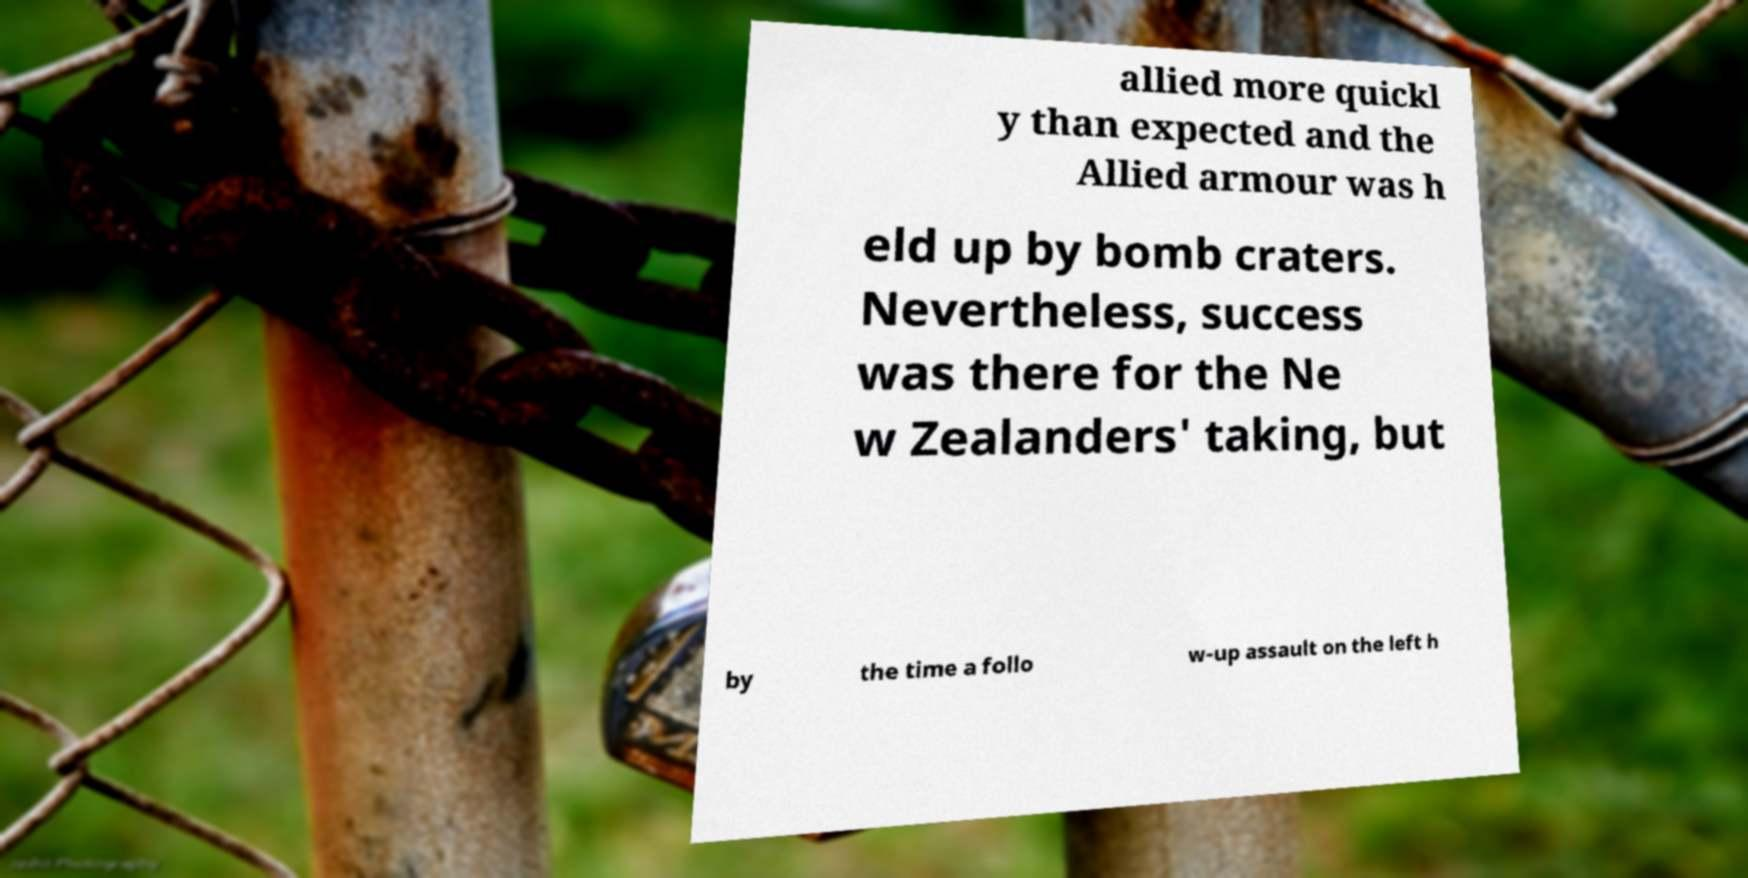Could you extract and type out the text from this image? allied more quickl y than expected and the Allied armour was h eld up by bomb craters. Nevertheless, success was there for the Ne w Zealanders' taking, but by the time a follo w-up assault on the left h 